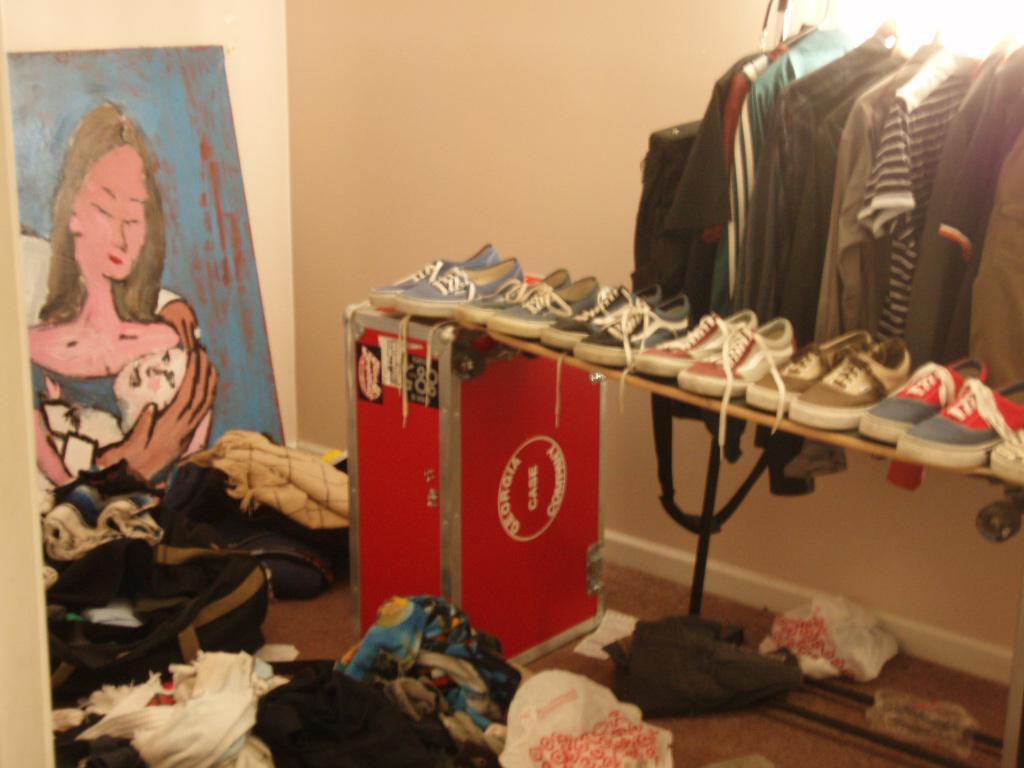Please provide a concise description of this image. In this image I can see there are few clothes arranged at right side, there is a light on right side. There are clothes on the floor and there is a painting at left side. 